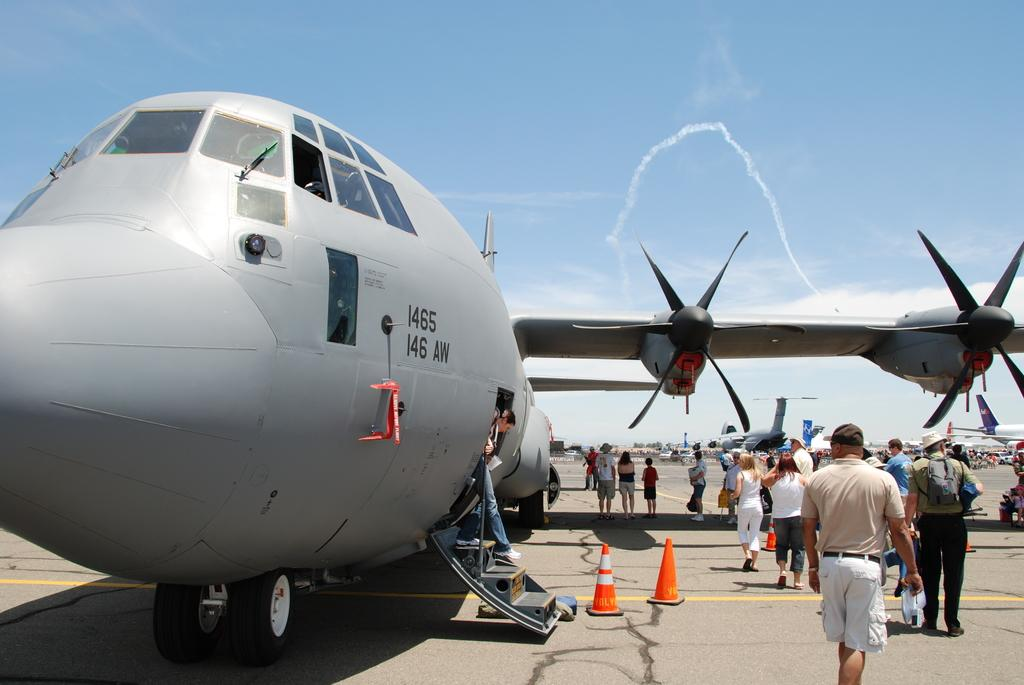Provide a one-sentence caption for the provided image. A group of people stand outside of a large propeller plane with the numerals 1465 on it. 